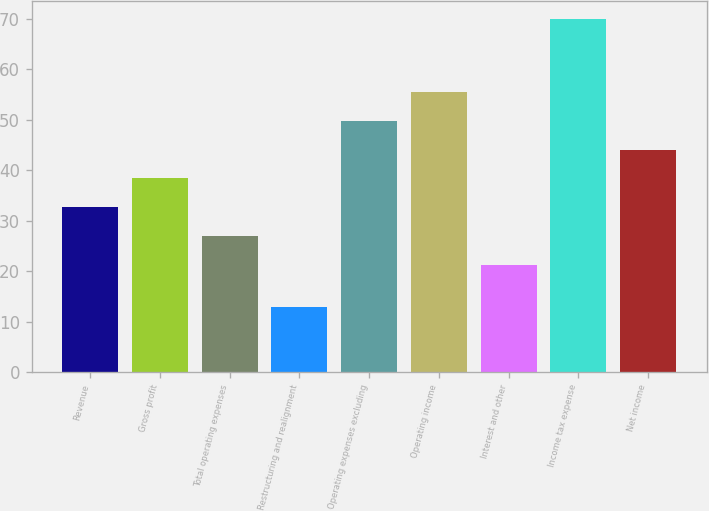Convert chart to OTSL. <chart><loc_0><loc_0><loc_500><loc_500><bar_chart><fcel>Revenue<fcel>Gross profit<fcel>Total operating expenses<fcel>Restructuring and realignment<fcel>Operating expenses excluding<fcel>Operating income<fcel>Interest and other<fcel>Income tax expense<fcel>Net income<nl><fcel>32.64<fcel>38.36<fcel>26.92<fcel>12.8<fcel>49.8<fcel>55.52<fcel>21.2<fcel>70<fcel>44.08<nl></chart> 